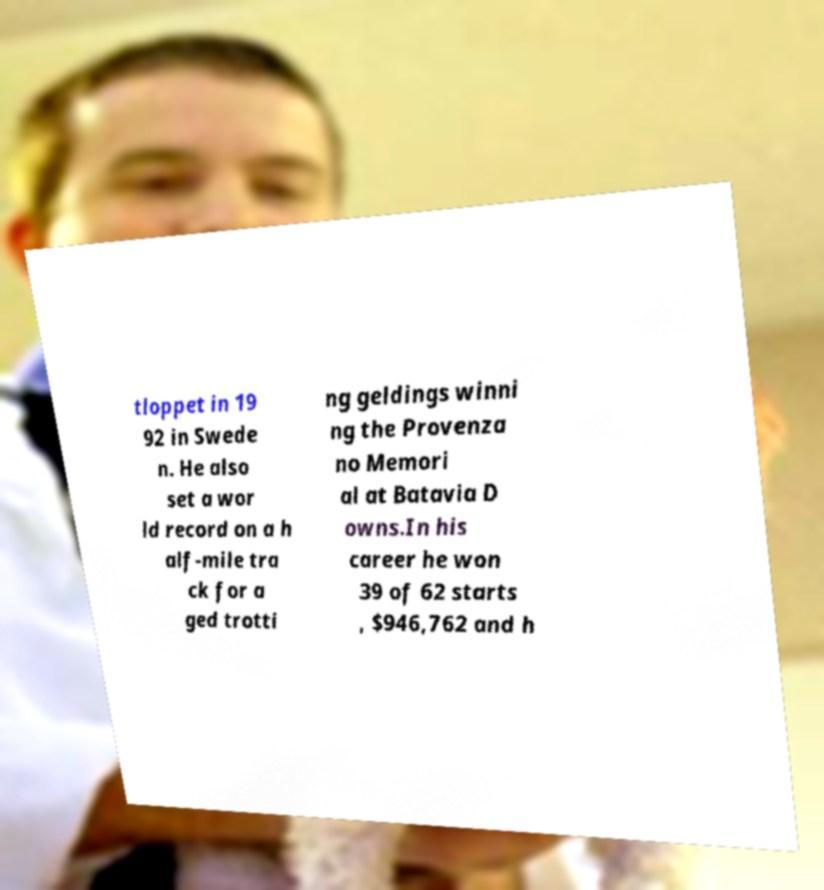Please identify and transcribe the text found in this image. tloppet in 19 92 in Swede n. He also set a wor ld record on a h alf-mile tra ck for a ged trotti ng geldings winni ng the Provenza no Memori al at Batavia D owns.In his career he won 39 of 62 starts , $946,762 and h 